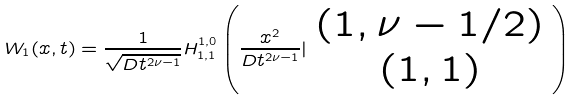Convert formula to latex. <formula><loc_0><loc_0><loc_500><loc_500>W _ { 1 } ( x , t ) = \frac { 1 } { \sqrt { D t ^ { 2 \nu - 1 } } } H _ { 1 , 1 } ^ { 1 , 0 } \left ( \frac { x ^ { 2 } } { D t ^ { 2 \nu - 1 } } | \begin{array} { c c } ( 1 , \nu - 1 / 2 ) \\ ( 1 , 1 ) \end{array} \right )</formula> 